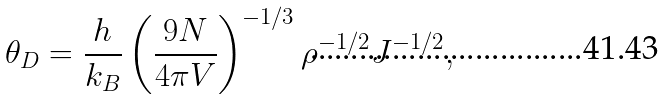<formula> <loc_0><loc_0><loc_500><loc_500>\theta _ { D } = \frac { h } { k _ { B } } \left ( \frac { 9 N } { 4 \pi V } \right ) ^ { - 1 / 3 } \rho ^ { - 1 / 2 } J ^ { - 1 / 2 } ,</formula> 